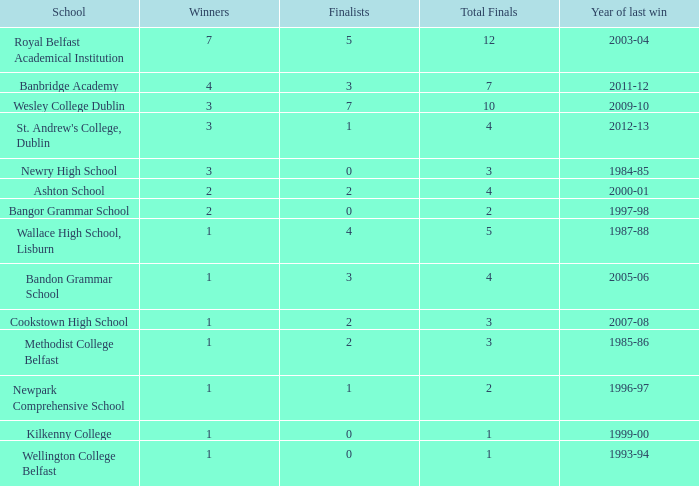When did the total number of finals amount to 10 in a year? 2009-10. 